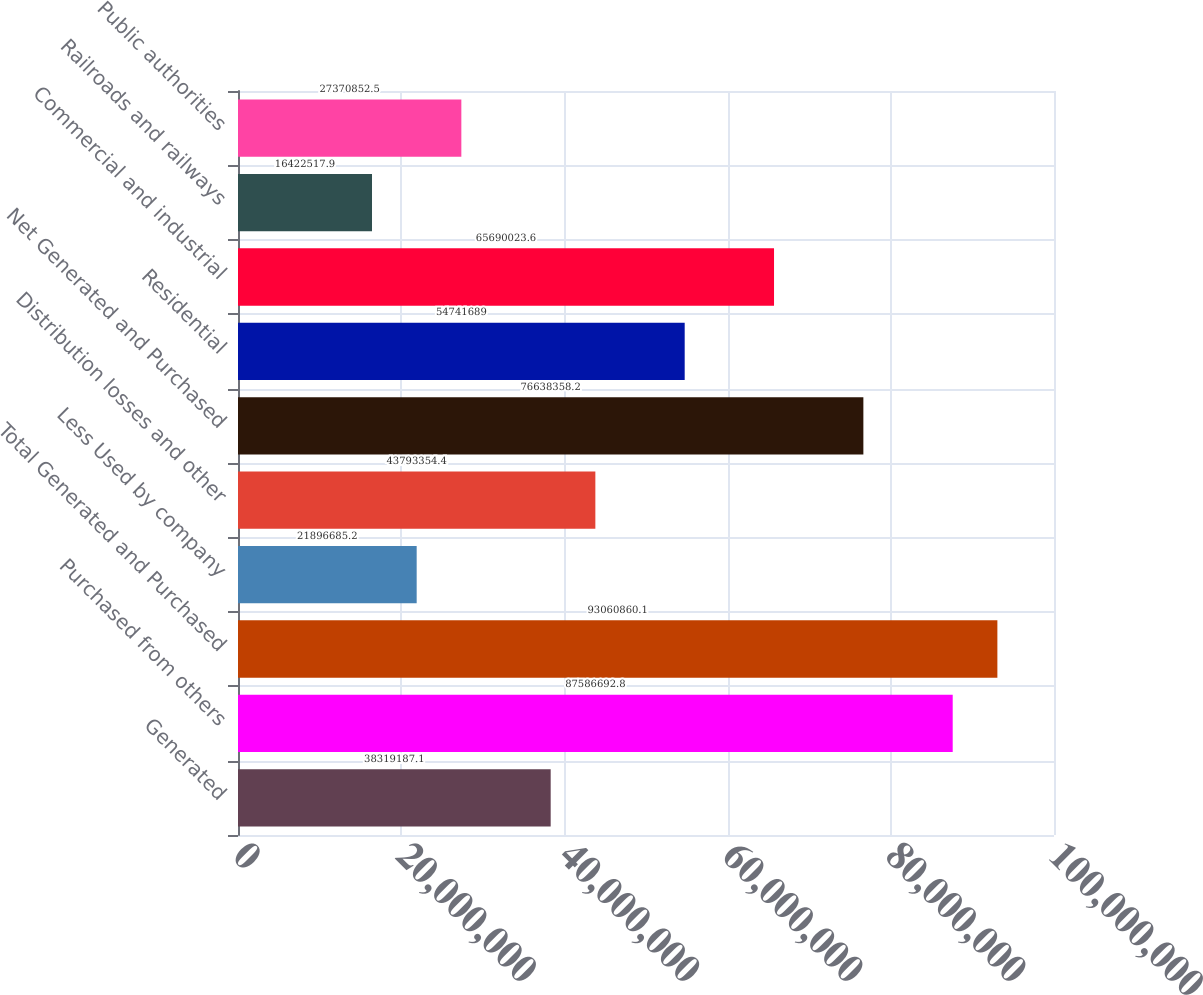Convert chart to OTSL. <chart><loc_0><loc_0><loc_500><loc_500><bar_chart><fcel>Generated<fcel>Purchased from others<fcel>Total Generated and Purchased<fcel>Less Used by company<fcel>Distribution losses and other<fcel>Net Generated and Purchased<fcel>Residential<fcel>Commercial and industrial<fcel>Railroads and railways<fcel>Public authorities<nl><fcel>3.83192e+07<fcel>8.75867e+07<fcel>9.30609e+07<fcel>2.18967e+07<fcel>4.37934e+07<fcel>7.66384e+07<fcel>5.47417e+07<fcel>6.569e+07<fcel>1.64225e+07<fcel>2.73709e+07<nl></chart> 